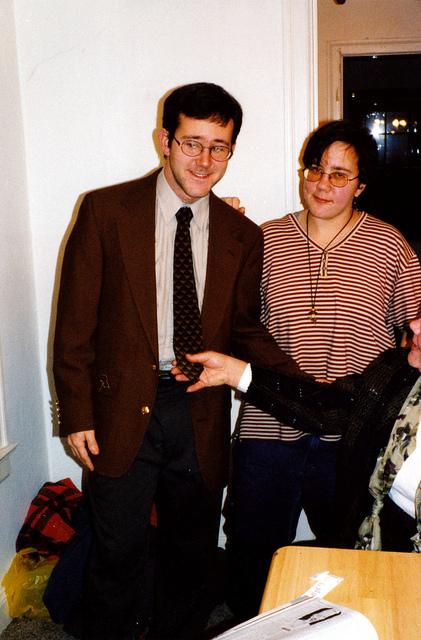Is the boy wearing a tie?
Quick response, please. Yes. Are both guys wearing formal clothes?
Answer briefly. No. Are the two wearing glasses?
Quick response, please. Yes. 